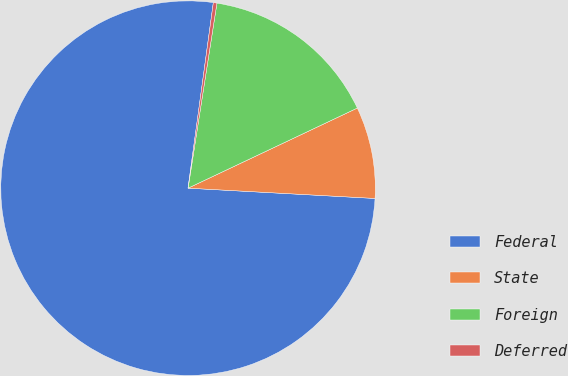Convert chart. <chart><loc_0><loc_0><loc_500><loc_500><pie_chart><fcel>Federal<fcel>State<fcel>Foreign<fcel>Deferred<nl><fcel>76.28%<fcel>7.91%<fcel>15.5%<fcel>0.31%<nl></chart> 